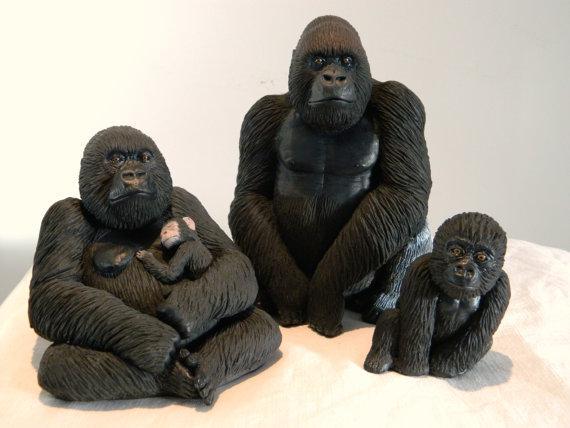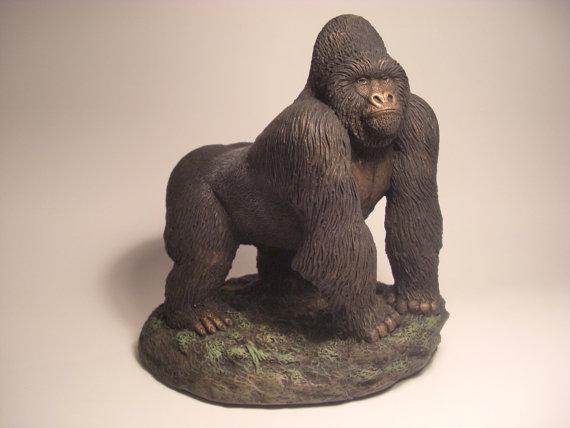The first image is the image on the left, the second image is the image on the right. Analyze the images presented: Is the assertion "The combined images include a gorilla with crossed arms and a gorilla on all fours, and at least one gorilla depicted is a real animal." valid? Answer yes or no. No. The first image is the image on the left, the second image is the image on the right. For the images shown, is this caption "There are more than 2 gorillas depicted." true? Answer yes or no. Yes. 